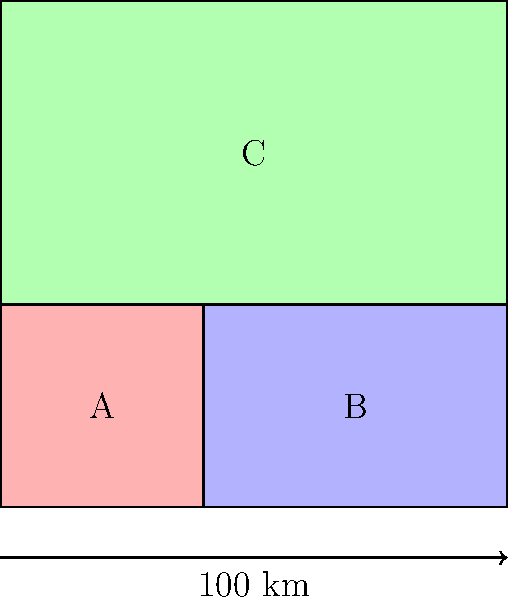In the given district map, which characteristic of the districts suggests potential gerrymandering, and how might image recognition techniques be applied to detect this pattern systematically across multiple maps? To analyze this district map for potential gerrymandering using image recognition techniques, we should consider the following steps:

1. Shape Analysis:
   - District A has an unusual, compact square shape.
   - Districts B and C have more irregular, elongated shapes.
   - Image recognition can detect and quantify these shape irregularities.

2. Size Comparison:
   - District C is significantly larger than A and B.
   - Machine learning algorithms can calculate and compare district areas.

3. Boundary Complexity:
   - Districts B and C have more complex boundaries than A.
   - Edge detection algorithms can measure boundary complexity.

4. Color Distribution:
   - The three districts have different colors, potentially representing different political leanings.
   - Color analysis can identify patterns of political segregation.

5. Contiguity:
   - All districts appear contiguous, but this should be verified.
   - Connectivity algorithms can ensure district continuity.

6. Population Density Estimation:
   - Assuming uniform population distribution, C likely has a different population density.
   - Density estimation techniques can flag potential population packing or cracking.

7. Compactness Measures:
   - Calculate compactness scores (e.g., Polsby-Popper score: $\frac{4\pi A}{P^2}$, where A is area and P is perimeter).
   - Compare scores across districts and with established benchmarks.

8. Pattern Recognition:
   - Train models to recognize common gerrymandering patterns (e.g., "cracking" or "packing").
   - Apply these models across multiple maps for systematic detection.

9. Statistical Analysis:
   - Compare district characteristics to expected distributions.
   - Flag significant deviations as potential gerrymandering indicators.

10. Machine Learning Classification:
    - Use features extracted from steps 1-9 to train a classifier.
    - Apply the classifier to new maps to identify potential gerrymandering.

The main characteristic suggesting potential gerrymandering is the irregular shapes of districts B and C compared to A, combined with their size differences. Image recognition techniques can systematically detect these patterns by quantifying shape irregularities, size disparities, and boundary complexities across multiple maps, feeding this data into machine learning models trained to identify gerrymandering patterns.
Answer: Irregular shapes and size disparities of districts B and C; apply shape analysis, boundary complexity measurement, and size comparison algorithms across multiple maps. 